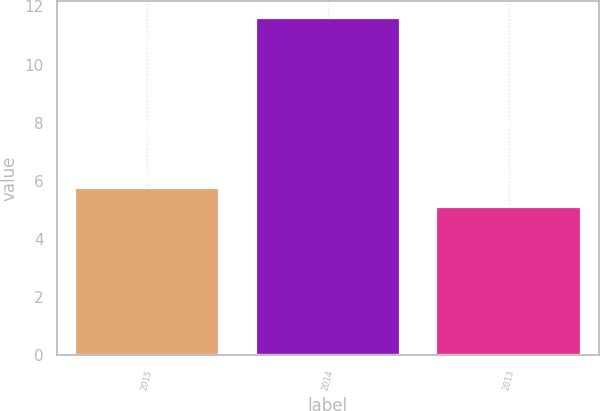Convert chart to OTSL. <chart><loc_0><loc_0><loc_500><loc_500><bar_chart><fcel>2015<fcel>2014<fcel>2013<nl><fcel>5.75<fcel>11.6<fcel>5.1<nl></chart> 